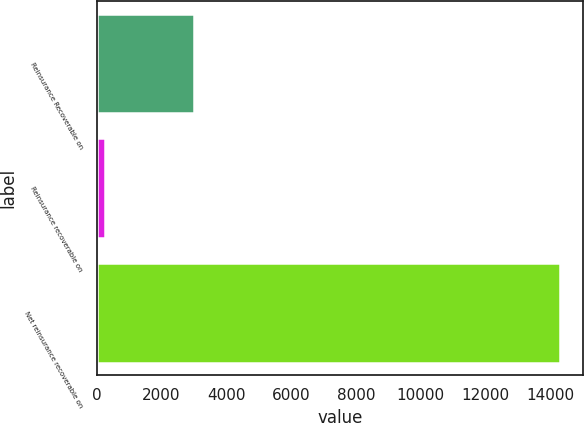Convert chart. <chart><loc_0><loc_0><loc_500><loc_500><bar_chart><fcel>Reinsurance Recoverable on<fcel>Reinsurance recoverable on<fcel>Net reinsurance recoverable on<nl><fcel>2990.6<fcel>259<fcel>14300.8<nl></chart> 